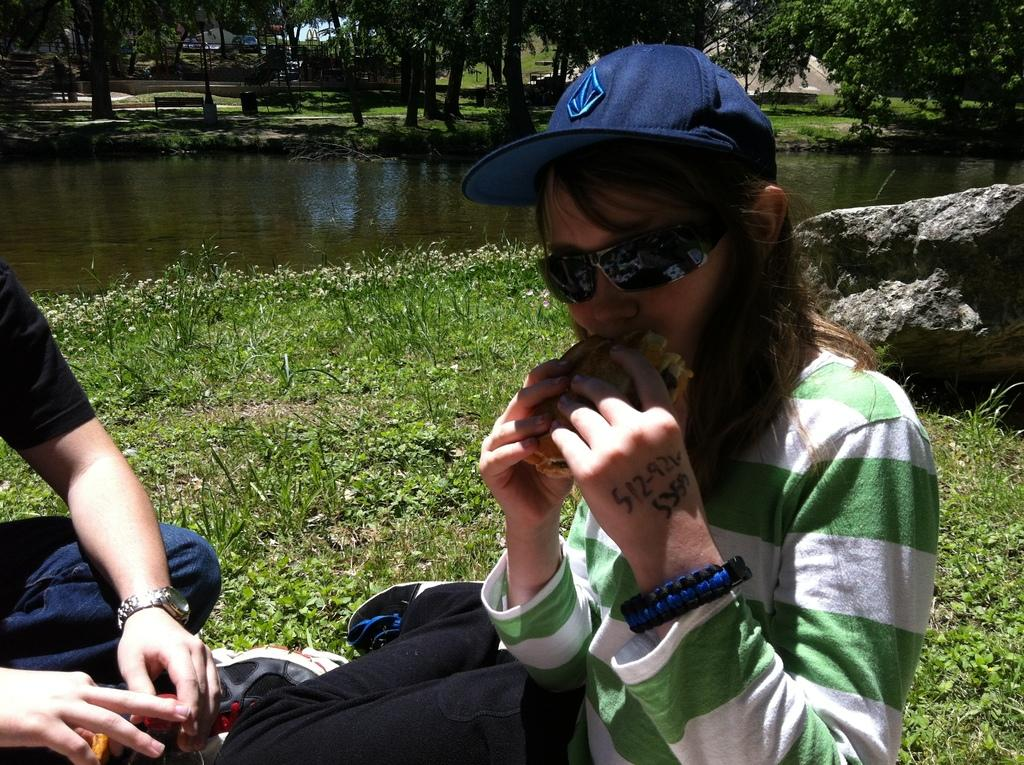How many people are sitting on the ground in the image? There are two people sitting on the ground in the image. What is the woman doing in the image? The woman is eating food with her hands in the image. What can be seen in the background of the image? There is a rock, water, trees, and benches in the background of the image. What is the caption of the image? There is no caption present in the image. Can you see a tiger in the image? No, there is no tiger present in the image. 